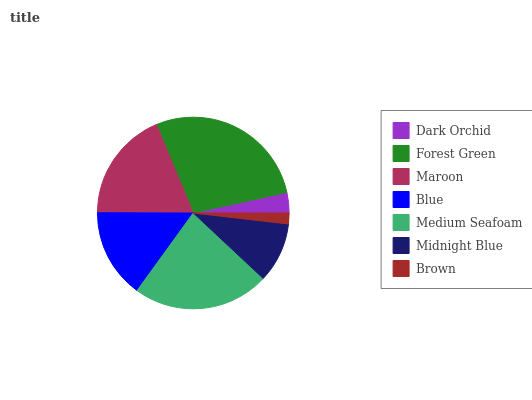Is Brown the minimum?
Answer yes or no. Yes. Is Forest Green the maximum?
Answer yes or no. Yes. Is Maroon the minimum?
Answer yes or no. No. Is Maroon the maximum?
Answer yes or no. No. Is Forest Green greater than Maroon?
Answer yes or no. Yes. Is Maroon less than Forest Green?
Answer yes or no. Yes. Is Maroon greater than Forest Green?
Answer yes or no. No. Is Forest Green less than Maroon?
Answer yes or no. No. Is Blue the high median?
Answer yes or no. Yes. Is Blue the low median?
Answer yes or no. Yes. Is Midnight Blue the high median?
Answer yes or no. No. Is Dark Orchid the low median?
Answer yes or no. No. 